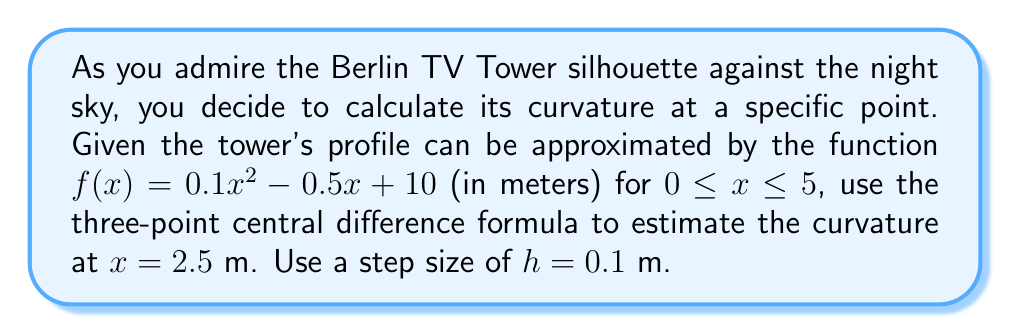What is the answer to this math problem? To solve this problem, we'll follow these steps:

1) Recall the formula for curvature:

   $$\kappa = \frac{|f''(x)|}{(1 + [f'(x)]^2)^{3/2}}$$

2) We need to estimate $f'(x)$ and $f''(x)$ using numerical differentiation.

3) For $f'(x)$, we'll use the central difference formula:

   $$f'(x) \approx \frac{f(x+h) - f(x-h)}{2h}$$

4) For $f''(x)$, we'll use the three-point central difference formula:

   $$f''(x) \approx \frac{f(x+h) - 2f(x) + f(x-h)}{h^2}$$

5) Calculate $f(2.4)$, $f(2.5)$, and $f(2.6)$:

   $f(2.4) = 0.1(2.4)^2 - 0.5(2.4) + 10 = 9.076$
   $f(2.5) = 0.1(2.5)^2 - 0.5(2.5) + 10 = 9.125$
   $f(2.6) = 0.1(2.6)^2 - 0.5(2.6) + 10 = 9.176$

6) Estimate $f'(2.5)$:

   $$f'(2.5) \approx \frac{9.176 - 9.076}{2(0.1)} = 0.5$$

7) Estimate $f''(2.5)$:

   $$f''(2.5) \approx \frac{9.176 - 2(9.125) + 9.076}{(0.1)^2} = 0.2$$

8) Now we can calculate the curvature:

   $$\kappa = \frac{|0.2|}{(1 + 0.5^2)^{3/2}} \approx 0.1562$$

Thus, the estimated curvature of the Berlin TV Tower's silhouette at $x = 2.5$ m is approximately 0.1562 m^(-1).
Answer: $0.1562$ m^(-1) 